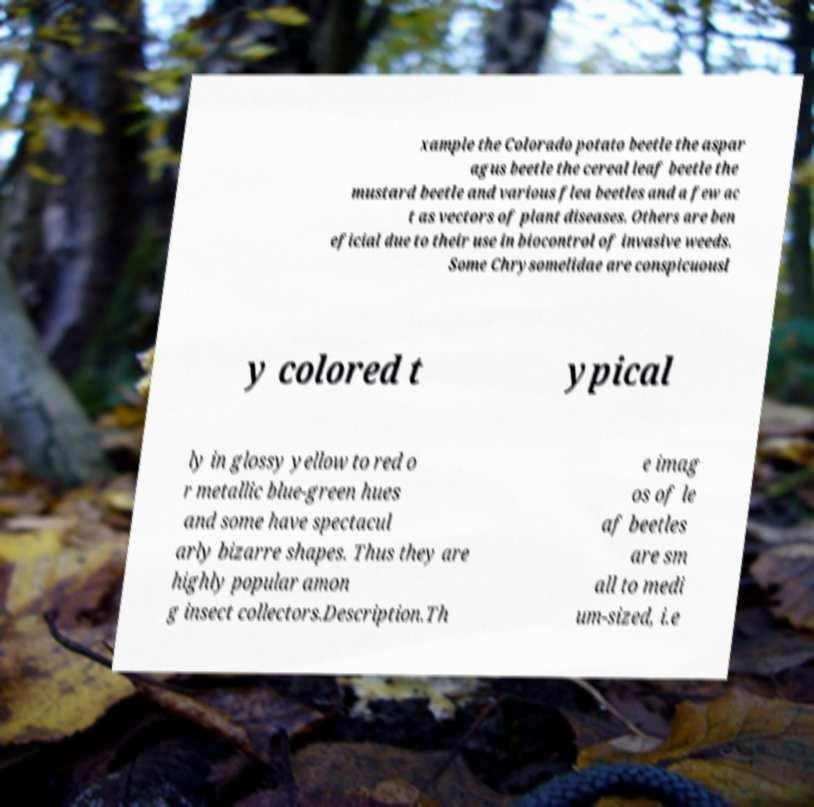I need the written content from this picture converted into text. Can you do that? xample the Colorado potato beetle the aspar agus beetle the cereal leaf beetle the mustard beetle and various flea beetles and a few ac t as vectors of plant diseases. Others are ben eficial due to their use in biocontrol of invasive weeds. Some Chrysomelidae are conspicuousl y colored t ypical ly in glossy yellow to red o r metallic blue-green hues and some have spectacul arly bizarre shapes. Thus they are highly popular amon g insect collectors.Description.Th e imag os of le af beetles are sm all to medi um-sized, i.e 